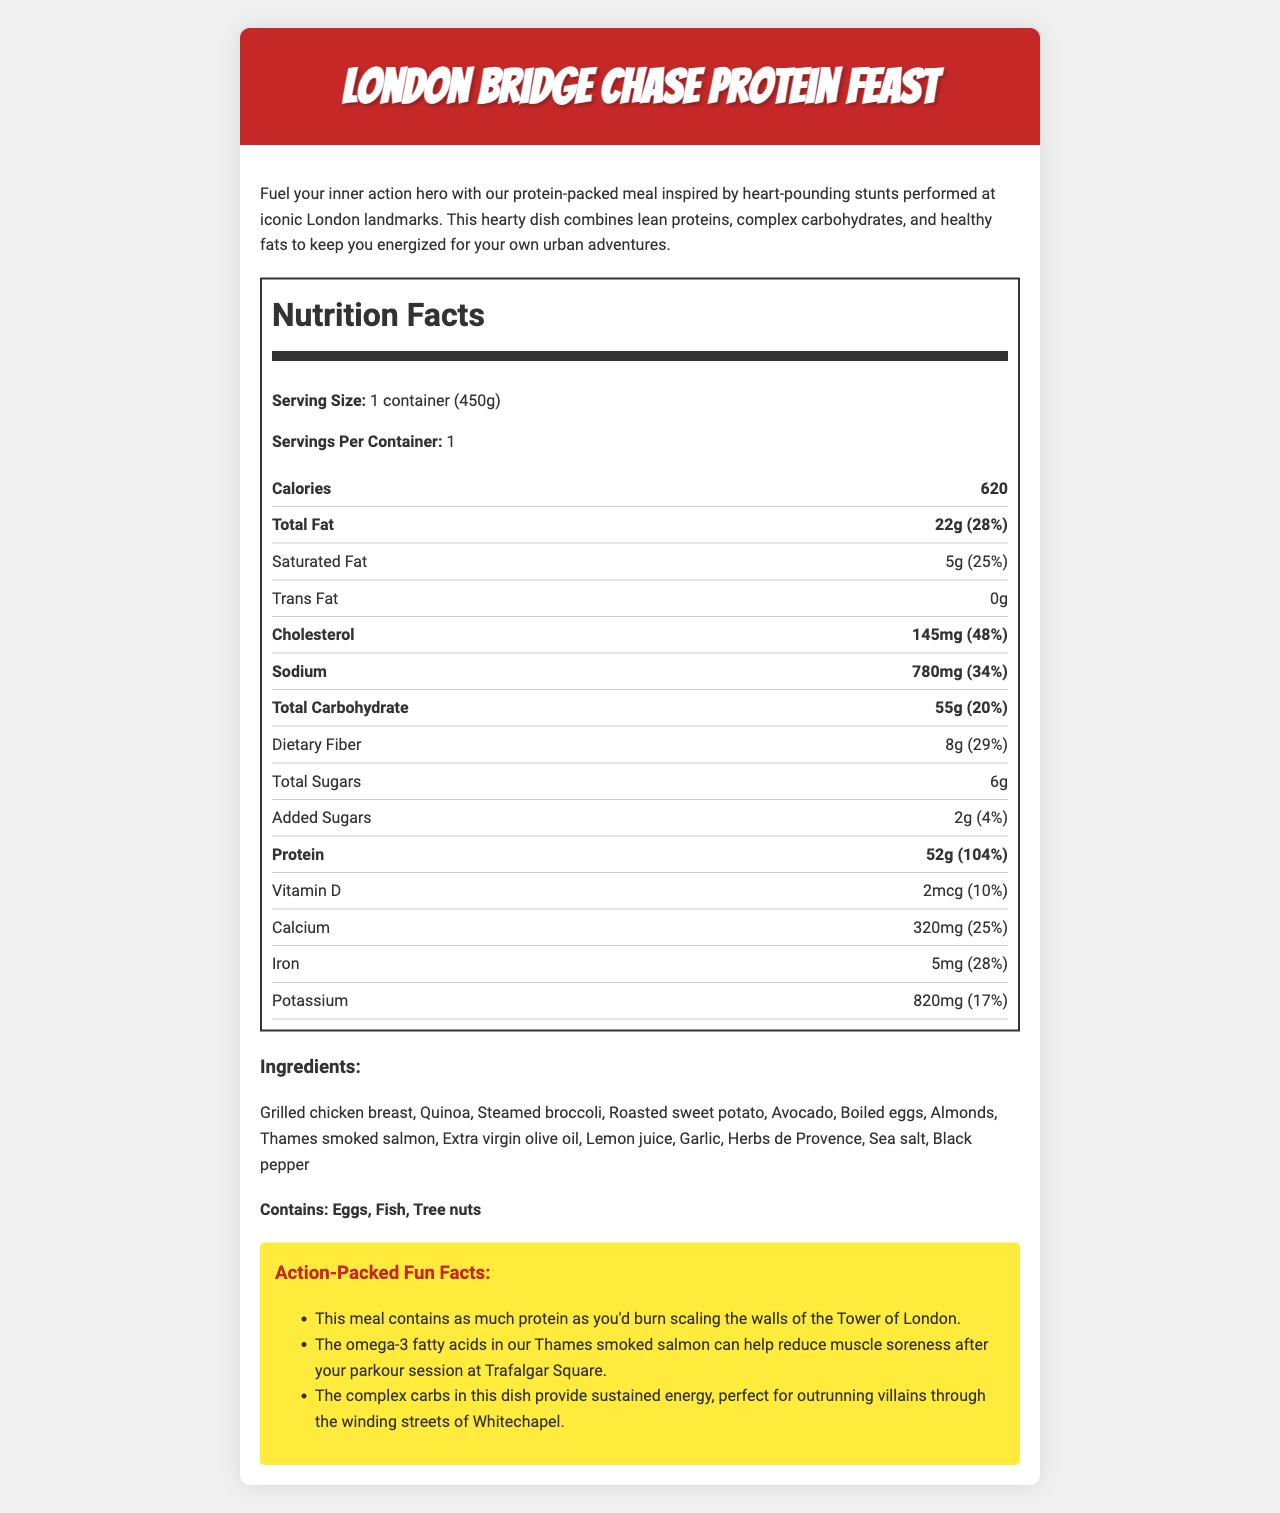what is the serving size of the London Bridge Chase Protein Feast? The serving size is provided in the Nutrition Facts section and states "1 container (450g)".
Answer: 1 container (450g) how many calories are in one serving of this meal? The number of calories is listed under the Nutrition Facts section, which shows 620 calories.
Answer: 620 what is the total fat content and its daily value percentage in this meal? The Nutrition Facts indicate that the total fat content is 22 grams, which is 28% of the daily value.
Answer: 22g (28%) how much protein is in this meal? The protein content is listed as 52 grams in the Nutrition Facts section.
Answer: 52g how much vitamin D does this meal provide? Vitamin D is listed in the Nutrition Facts with an amount of 2 mcg and a daily value of 10%.
Answer: 2 mcg (10%) what are the allergens included in this meal? The allergens are mentioned in the "Contains" section, listing eggs, fish, and tree nuts.
Answer: Eggs, Fish, Tree nuts which ingredient in this meal is specific to a London landmark? A. Boiled eggs B. Thames smoked salmon C. Avocado Thames smoked salmon is the ingredient specific to a London landmark.
Answer: B how many grams of dietary fiber does this meal contain? A. 4g B. 6g C. 8g The Nutrition Facts indicate that the dietary fiber content is 8 grams.
Answer: C what are the complex carbohydrates sources in this meal mentioned in the fun facts section? A. Grilled chicken breast B. Quinoa C. Avocado The fun facts section mentions that complex carbohydrates in the dish provide sustained energy, and quinoa is listed as an ingredient.
Answer: B has this meal added sugars? The Nutrition Facts list added sugars with an amount of 2g (4% daily value).
Answer: Yes describe the overall focus and contents of the document. The document describes the London Bridge Chase Protein Feast, detailing its nutritional facts, ingredients, allergens, and fun facts related to London landmarks, providing insights into the meal's composition and benefits.
Answer: Nutrition details of a protein-packed meal inspired by London action film stunts. is the amount of trans fat in this meal zero? The Nutrition Facts section lists trans fat as 0g.
Answer: Yes does the meal provide more than 100% daily value of protein? True or False The protein content is 52g, which is 104% of the daily value, indicating more than 100%.
Answer: True compare the daily values of sodium and cholesterol in this meal. Sodium has a daily value of 34%, while cholesterol has a daily value of 48%, as stated in the Nutrition Facts.
Answer: Sodium: 34%, Cholesterol: 48% can we determine how much garlic is used in the meal? The document lists garlic as an ingredient but does not provide specific quantities for each ingredient, making it impossible to determine the amount used.
Answer: Not enough information 